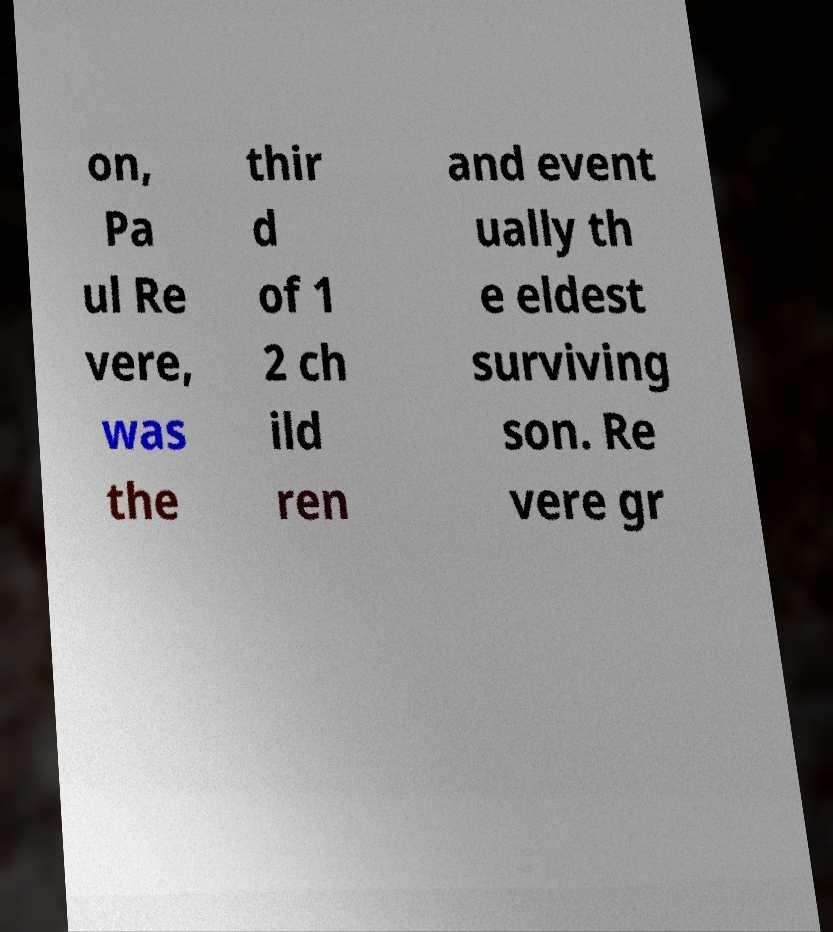For documentation purposes, I need the text within this image transcribed. Could you provide that? on, Pa ul Re vere, was the thir d of 1 2 ch ild ren and event ually th e eldest surviving son. Re vere gr 